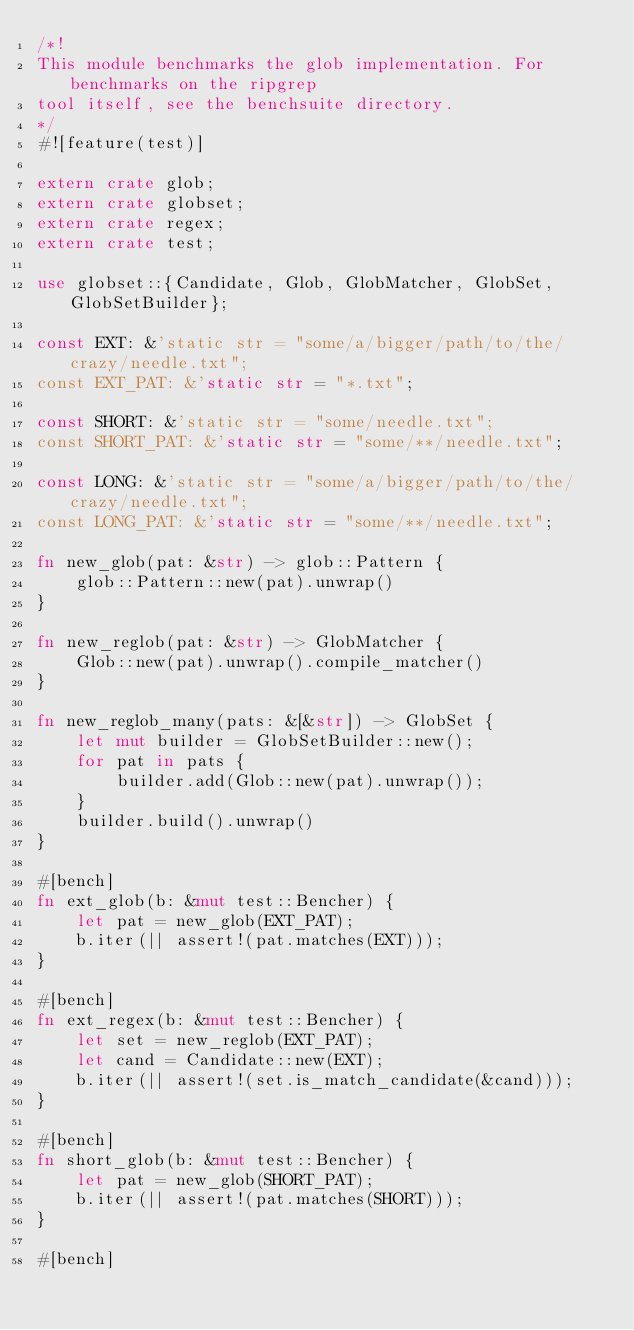<code> <loc_0><loc_0><loc_500><loc_500><_Rust_>/*!
This module benchmarks the glob implementation. For benchmarks on the ripgrep
tool itself, see the benchsuite directory.
*/
#![feature(test)]

extern crate glob;
extern crate globset;
extern crate regex;
extern crate test;

use globset::{Candidate, Glob, GlobMatcher, GlobSet, GlobSetBuilder};

const EXT: &'static str = "some/a/bigger/path/to/the/crazy/needle.txt";
const EXT_PAT: &'static str = "*.txt";

const SHORT: &'static str = "some/needle.txt";
const SHORT_PAT: &'static str = "some/**/needle.txt";

const LONG: &'static str = "some/a/bigger/path/to/the/crazy/needle.txt";
const LONG_PAT: &'static str = "some/**/needle.txt";

fn new_glob(pat: &str) -> glob::Pattern {
    glob::Pattern::new(pat).unwrap()
}

fn new_reglob(pat: &str) -> GlobMatcher {
    Glob::new(pat).unwrap().compile_matcher()
}

fn new_reglob_many(pats: &[&str]) -> GlobSet {
    let mut builder = GlobSetBuilder::new();
    for pat in pats {
        builder.add(Glob::new(pat).unwrap());
    }
    builder.build().unwrap()
}

#[bench]
fn ext_glob(b: &mut test::Bencher) {
    let pat = new_glob(EXT_PAT);
    b.iter(|| assert!(pat.matches(EXT)));
}

#[bench]
fn ext_regex(b: &mut test::Bencher) {
    let set = new_reglob(EXT_PAT);
    let cand = Candidate::new(EXT);
    b.iter(|| assert!(set.is_match_candidate(&cand)));
}

#[bench]
fn short_glob(b: &mut test::Bencher) {
    let pat = new_glob(SHORT_PAT);
    b.iter(|| assert!(pat.matches(SHORT)));
}

#[bench]</code> 